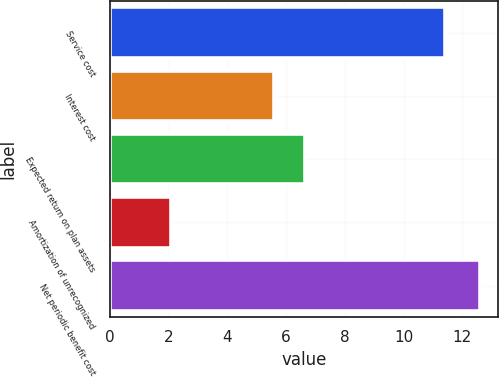Convert chart. <chart><loc_0><loc_0><loc_500><loc_500><bar_chart><fcel>Service cost<fcel>Interest cost<fcel>Expected return on plan assets<fcel>Amortization of unrecognized<fcel>Net periodic benefit cost<nl><fcel>11.4<fcel>5.6<fcel>6.65<fcel>2.1<fcel>12.6<nl></chart> 